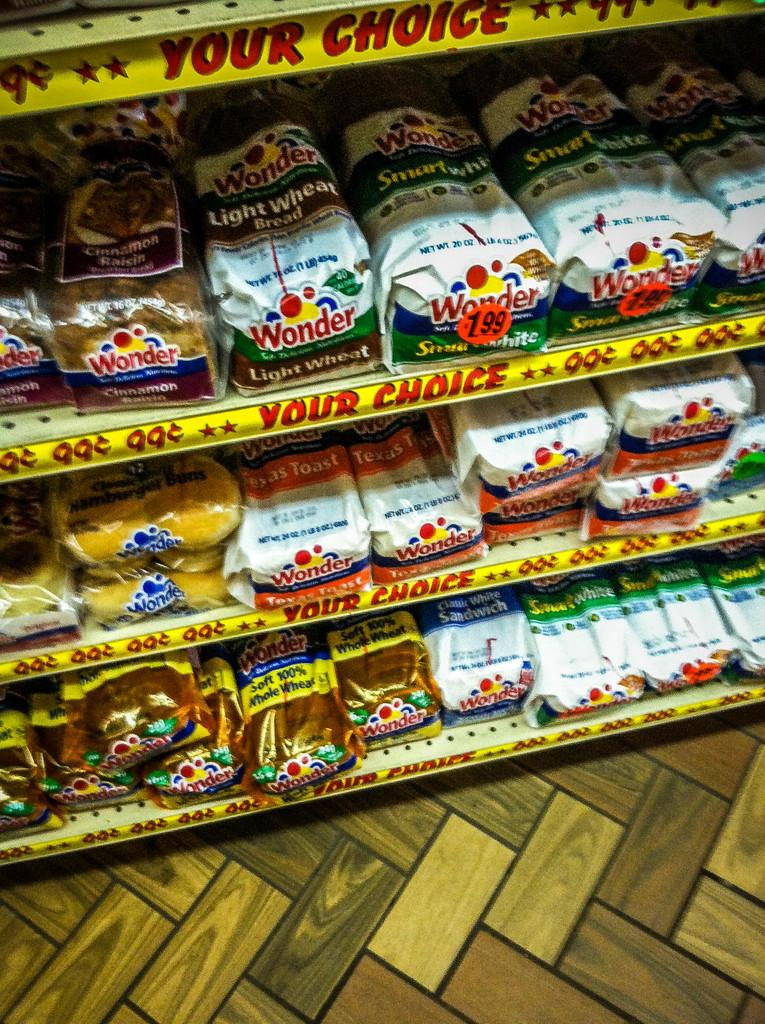<image>
Offer a succinct explanation of the picture presented. Bread for sale including Wonder bread for 1.99 